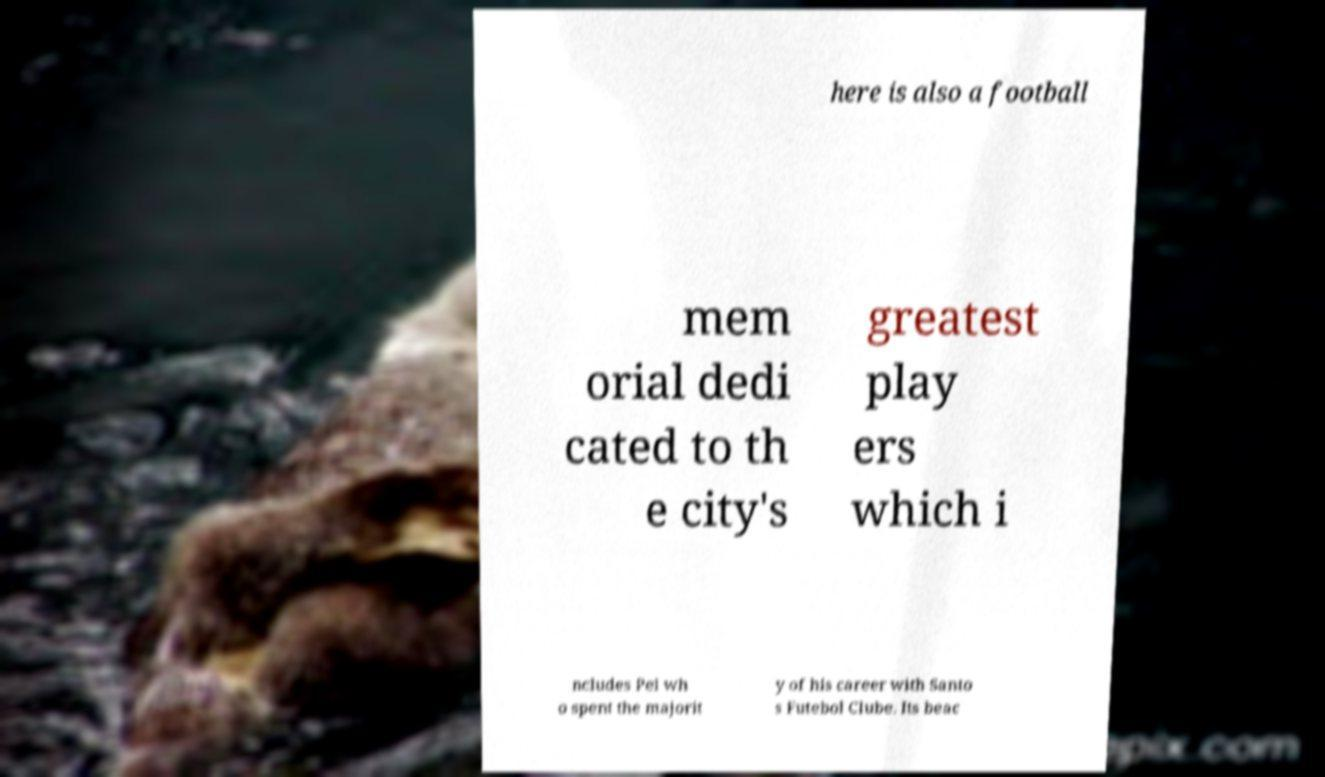Please read and relay the text visible in this image. What does it say? here is also a football mem orial dedi cated to th e city's greatest play ers which i ncludes Pel wh o spent the majorit y of his career with Santo s Futebol Clube. Its beac 